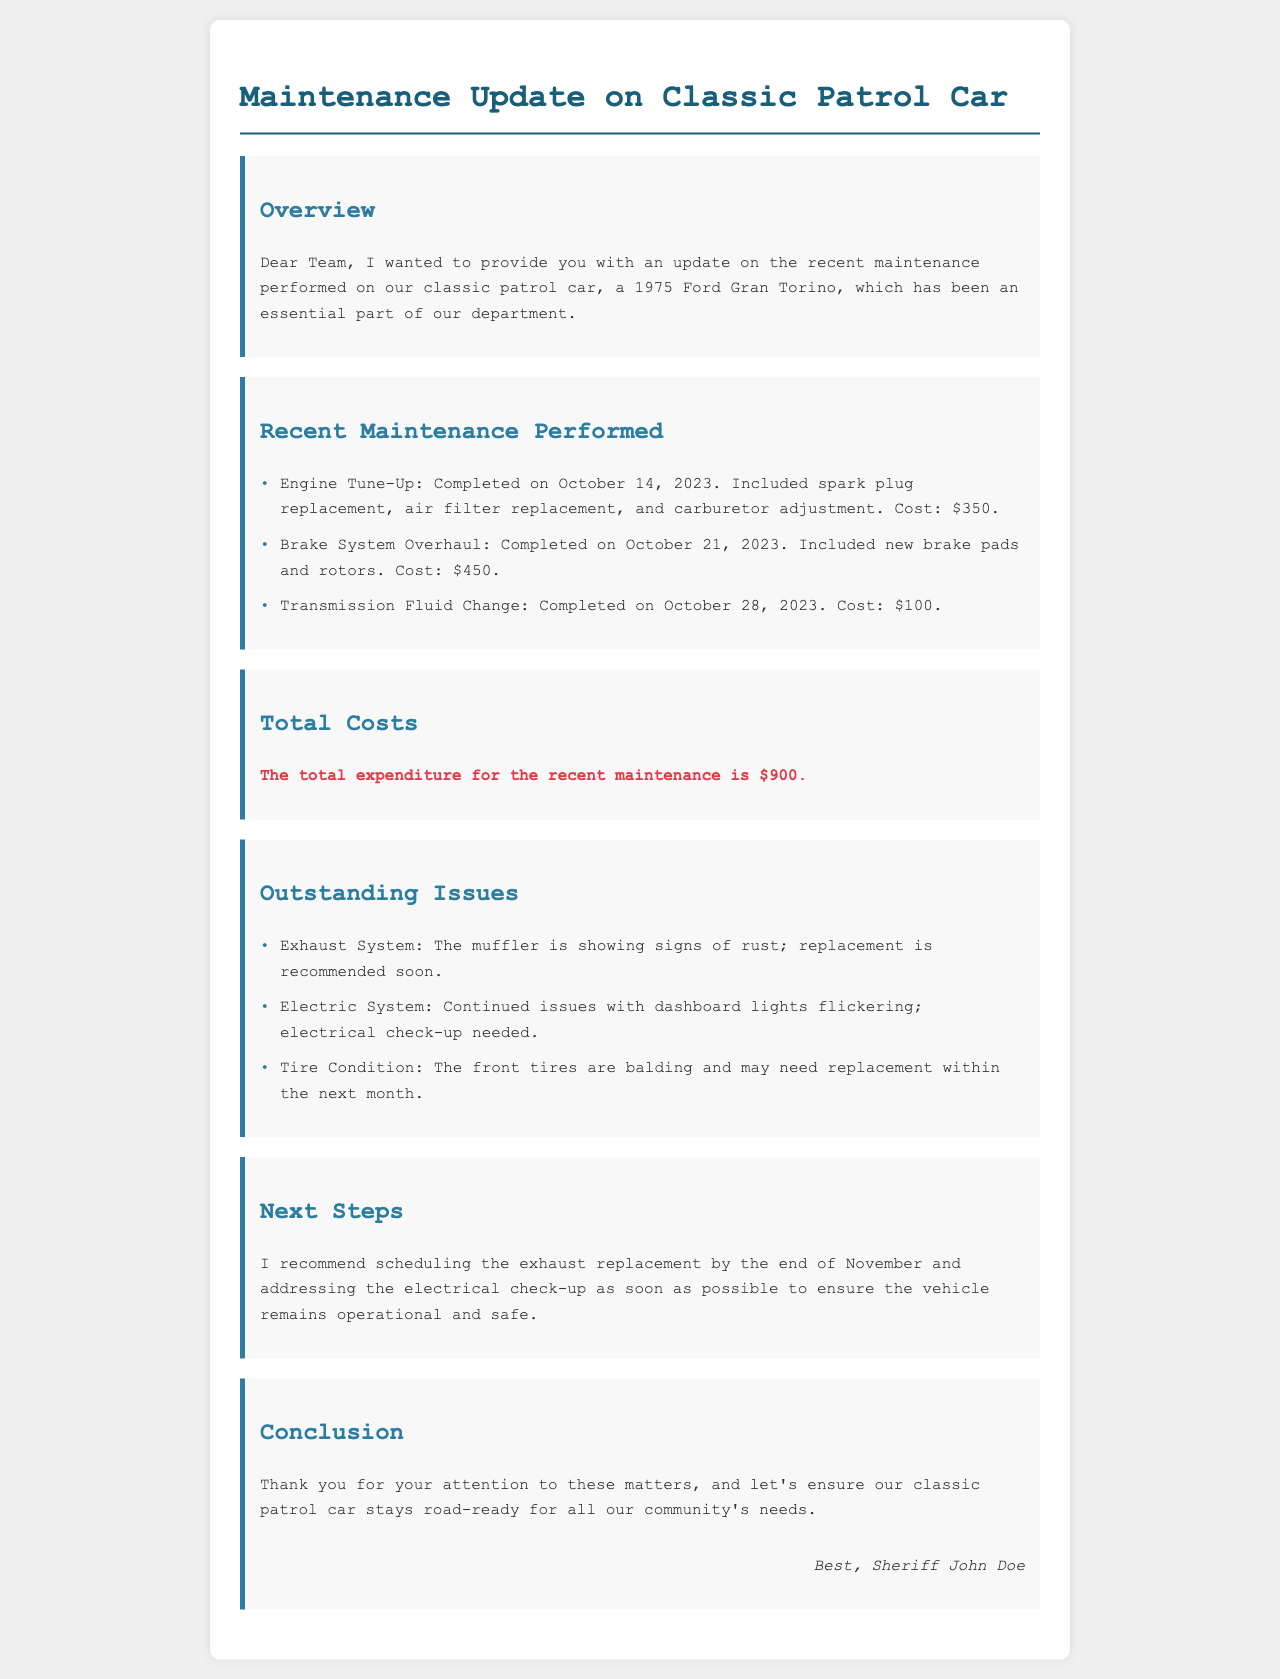What vehicle model is being discussed? The document mentions a 1975 Ford Gran Torino as the classic patrol car.
Answer: 1975 Ford Gran Torino When was the engine tune-up completed? The document states the engine tune-up was completed on October 14, 2023.
Answer: October 14, 2023 What was the cost of the brake system overhaul? The document lists the cost of the brake system overhaul as $450.
Answer: $450 What is the total expenditure for the recent maintenance? The document specifies that the total expenditure is $900.
Answer: $900 What outstanding issue is related to the exhaust system? The document states that the muffler is showing signs of rust and needs replacement soon.
Answer: Muffler rust What is recommended for the electrical system? The document indicates that an electrical check-up is needed due to flickering dashboard lights.
Answer: Electrical check-up When should the exhaust replacement be scheduled? The document recommends scheduling the exhaust replacement by the end of November.
Answer: End of November Who signed off on the maintenance update? The signature at the end of the document is from Sheriff John Doe.
Answer: Sheriff John Doe 